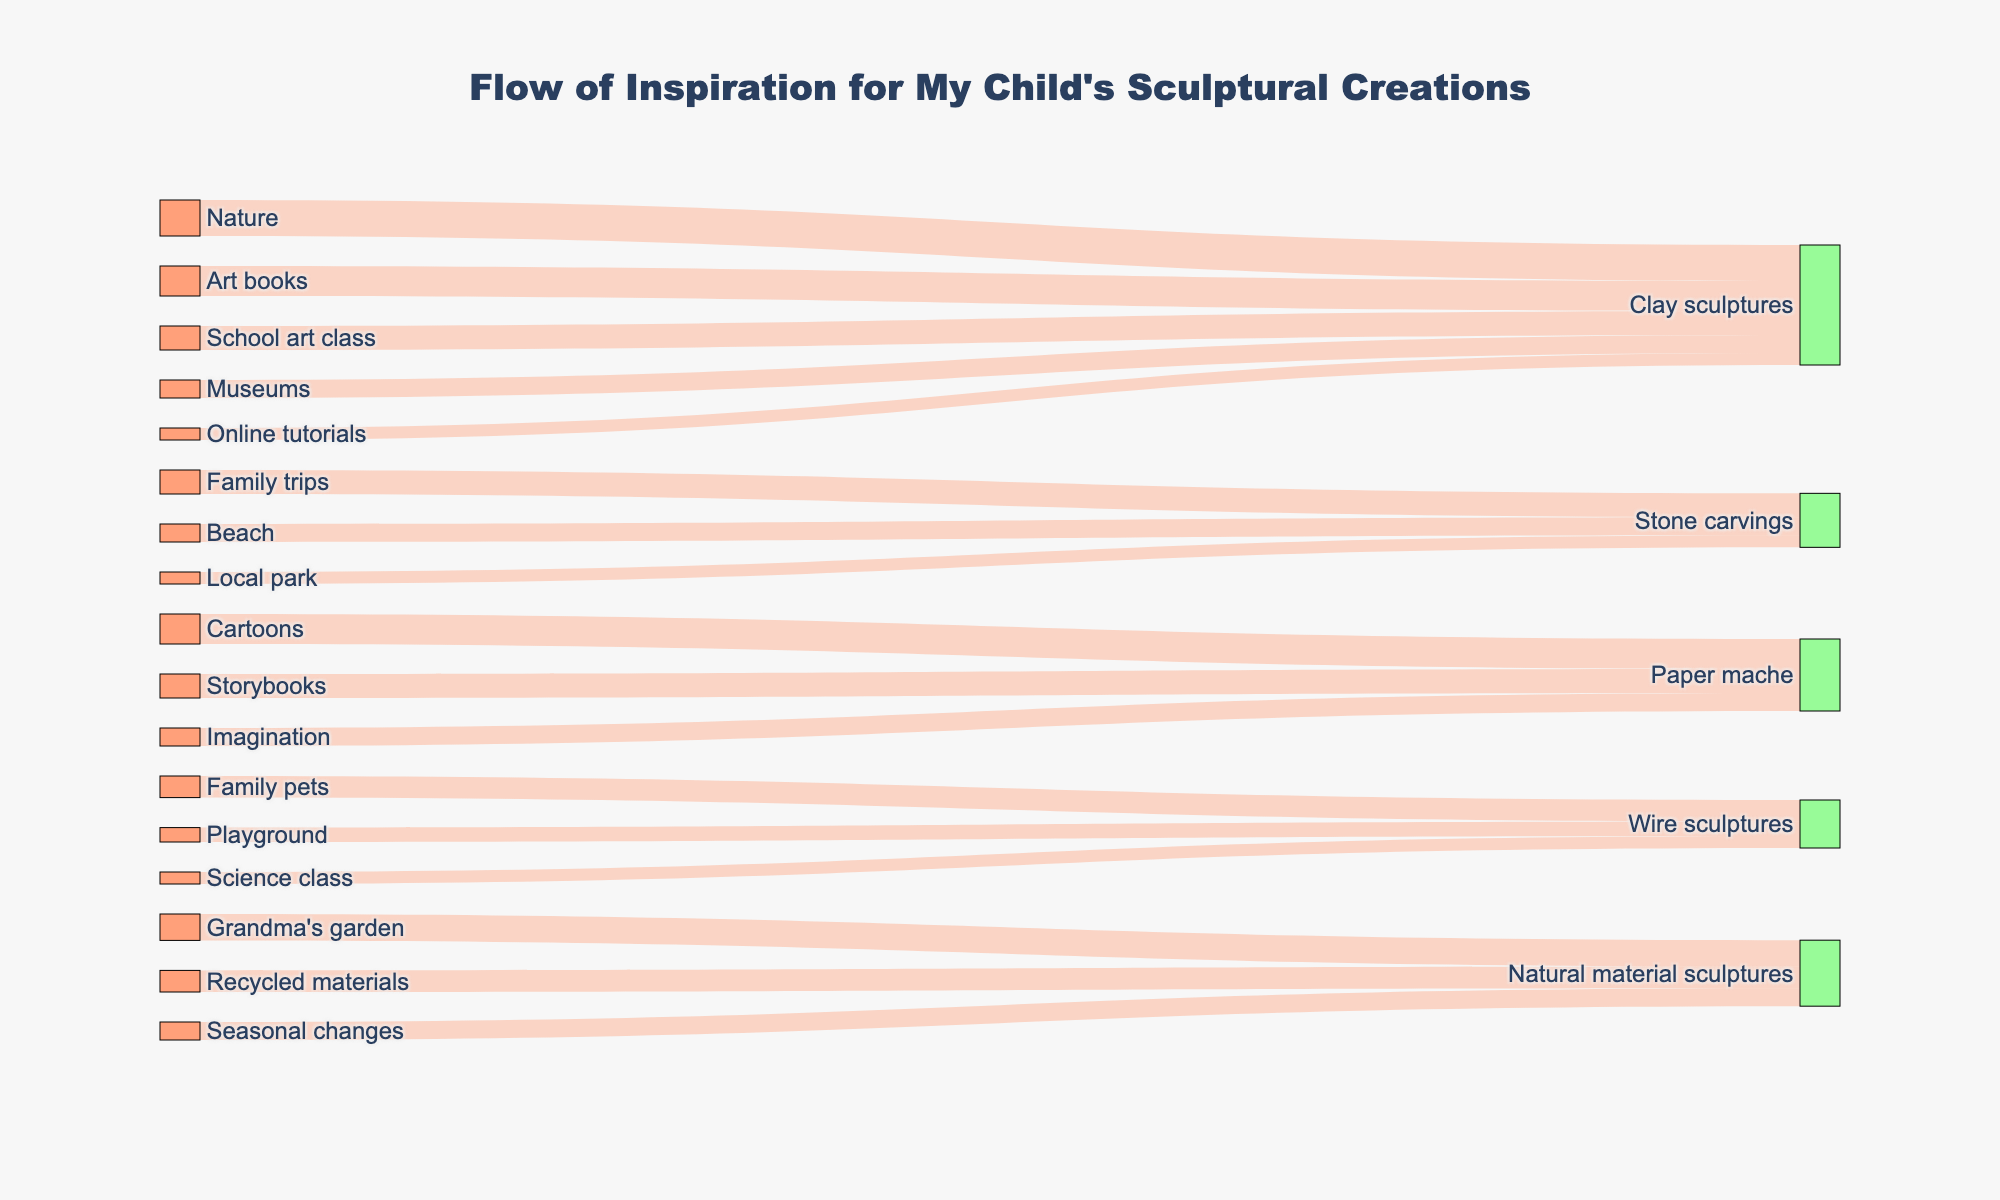What is the title of the Sankey diagram? The title of the diagram is usually found at the top of the figure in a larger and bolder font. In this case, it should be read directly from the main text above the visual elements
Answer: Flow of Inspiration for My Child's Sculptural Creations Which source of inspiration contributes the most to Clay sculptures? By examining the lengths and flows of the streams leading to Clay sculptures, the widest stream represents the largest contribution. The source Nature has the widest stream, contributing 30 units.
Answer: Nature How many inspiration sources contribute to Stone carvings? To identify the sources contributing to Stone carvings, we count all unique sources linked to it. The diagram shows 3 sources: Family trips, Beach, and Local park.
Answer: 3 What is the total inspiration value for Wire sculptures? To find the total, sum the values of all sources contributing to Wire sculptures: Family pets (18) + Playground (12) + Science class (10) = 40
Answer: 40 Which sculptural creation receives the least inspiration from Online tutorials? Check the value associated with Online tutorials and identify its target node. Online tutorials contribute to Clay sculptures with a value of 10. Compare it with other sources; a value of 10 is the smallest number compared to other sources listed above.
Answer: Clay sculptures Compare the contribution from Art books to Clay sculptures with Storybooks to Paper mache. By looking at the widths and values of the streams, Art books to Clay sculptures is 25 units, while Storybooks to Paper mache is 20 units. Therefore, Art books contribute more than Storybooks.
Answer: Art books (25) > Storybooks (20) Which source provides an equal amount of inspiration to Natural material sculptures and Wire sculptures? Scan the values of the sources connected to both types of sculptures. Both Recycled materials, contributing 18 units to Natural material sculptures, and Family pets, with 18 units to Wire sculptures, are the same.
Answer: 18 units (Family pets and Recycled materials) What is the average inspiration contributed to Paper mache? First, sum the inspirations for Paper mache: Cartoons (25) + Storybooks (20) + Imagination (15) = 60. Then, divide by the number of sources, which is 3. The average is 60/3 = 20 units.
Answer: 20 Which source contributes more to Stone carvings: Beach or Local park? Compare the values directly. Beach contributions are 15 units, while Local park is 10 units. Thus, Beach contributes more.
Answer: Beach Identify the source with the smallest contribution to any sculptural creation and name the creation it contributes to. Rank the values from smallest. Online tutorials contribute 10 units, which is the smallest, and it is directed towards Clay sculptures.
Answer: Online tutorials, Clay sculptures 